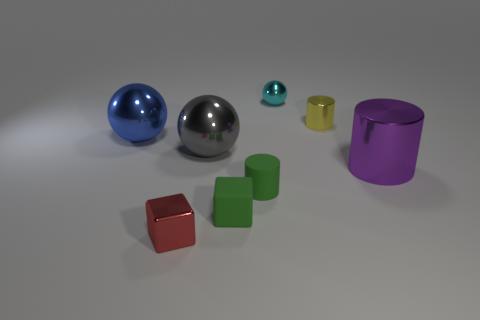How many small objects are behind the purple metallic cylinder and in front of the matte cube?
Offer a terse response. 0. What number of gray objects are either rubber objects or cubes?
Your answer should be compact. 0. Does the tiny thing right of the cyan shiny ball have the same color as the large shiny thing on the left side of the shiny block?
Provide a succinct answer. No. There is a metal cylinder that is left of the large metallic thing right of the small rubber object that is to the left of the matte cylinder; what is its color?
Give a very brief answer. Yellow. Are there any large blue objects in front of the block that is behind the red metal object?
Provide a short and direct response. No. Does the large thing that is right of the cyan metal ball have the same shape as the blue thing?
Your answer should be very brief. No. Is there anything else that has the same shape as the cyan object?
Give a very brief answer. Yes. What number of balls are either large gray rubber things or big purple objects?
Keep it short and to the point. 0. How many large blue metallic cubes are there?
Your response must be concise. 0. What is the size of the block in front of the small green rubber thing that is in front of the tiny green rubber cylinder?
Give a very brief answer. Small. 